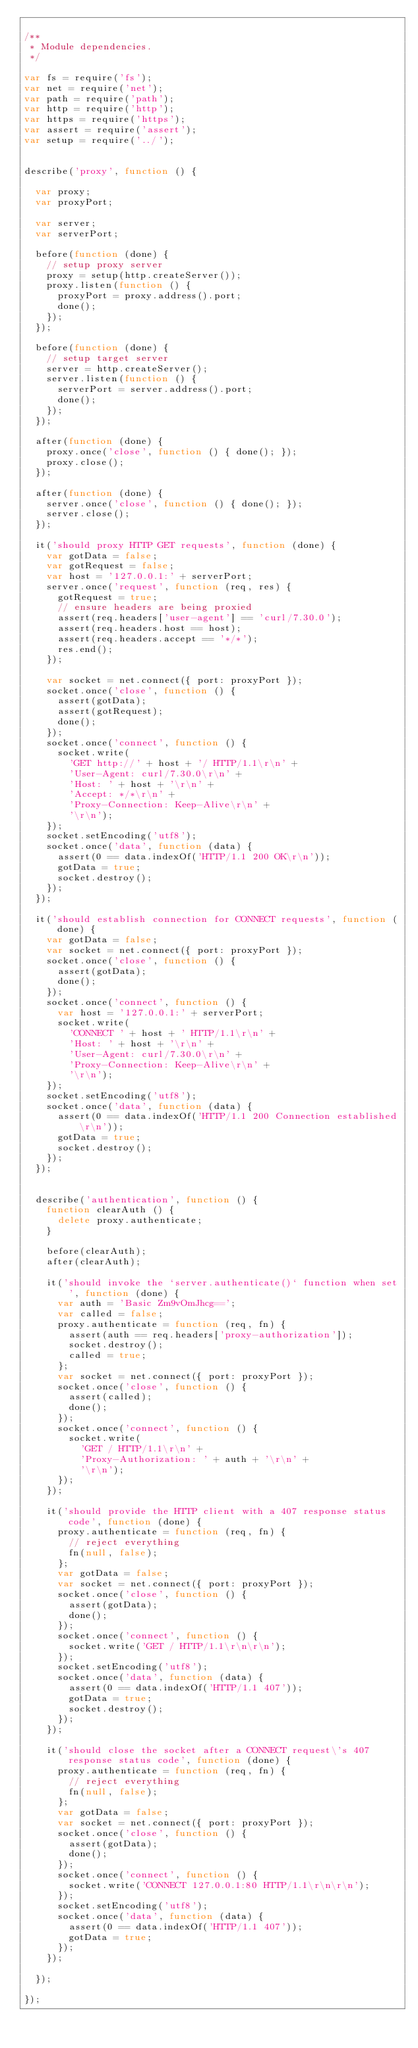<code> <loc_0><loc_0><loc_500><loc_500><_JavaScript_>
/**
 * Module dependencies.
 */

var fs = require('fs');
var net = require('net');
var path = require('path');
var http = require('http');
var https = require('https');
var assert = require('assert');
var setup = require('../');


describe('proxy', function () {

  var proxy;
  var proxyPort;

  var server;
  var serverPort;

  before(function (done) {
    // setup proxy server
    proxy = setup(http.createServer());
    proxy.listen(function () {
      proxyPort = proxy.address().port;
      done();
    });
  });

  before(function (done) {
    // setup target server
    server = http.createServer();
    server.listen(function () {
      serverPort = server.address().port;
      done();
    });
  });

  after(function (done) {
    proxy.once('close', function () { done(); });
    proxy.close();
  });

  after(function (done) {
    server.once('close', function () { done(); });
    server.close();
  });

  it('should proxy HTTP GET requests', function (done) {
    var gotData = false;
    var gotRequest = false;
    var host = '127.0.0.1:' + serverPort;
    server.once('request', function (req, res) {
      gotRequest = true;
      // ensure headers are being proxied
      assert(req.headers['user-agent'] == 'curl/7.30.0');
      assert(req.headers.host == host);
      assert(req.headers.accept == '*/*');
      res.end();
    });

    var socket = net.connect({ port: proxyPort });
    socket.once('close', function () {
      assert(gotData);
      assert(gotRequest);
      done();
    });
    socket.once('connect', function () {
      socket.write(
        'GET http://' + host + '/ HTTP/1.1\r\n' +
        'User-Agent: curl/7.30.0\r\n' +
        'Host: ' + host + '\r\n' +
        'Accept: */*\r\n' +
        'Proxy-Connection: Keep-Alive\r\n' +
        '\r\n');
    });
    socket.setEncoding('utf8');
    socket.once('data', function (data) {
      assert(0 == data.indexOf('HTTP/1.1 200 OK\r\n'));
      gotData = true;
      socket.destroy();
    });
  });

  it('should establish connection for CONNECT requests', function (done) {
    var gotData = false;
    var socket = net.connect({ port: proxyPort });
    socket.once('close', function () {
      assert(gotData);
      done();
    });
    socket.once('connect', function () {
      var host = '127.0.0.1:' + serverPort;
      socket.write(
        'CONNECT ' + host + ' HTTP/1.1\r\n' +
        'Host: ' + host + '\r\n' +
        'User-Agent: curl/7.30.0\r\n' +
        'Proxy-Connection: Keep-Alive\r\n' +
        '\r\n');
    });
    socket.setEncoding('utf8');
    socket.once('data', function (data) {
      assert(0 == data.indexOf('HTTP/1.1 200 Connection established\r\n'));
      gotData = true;
      socket.destroy();
    });
  });


  describe('authentication', function () {
    function clearAuth () {
      delete proxy.authenticate;
    }

    before(clearAuth);
    after(clearAuth);

    it('should invoke the `server.authenticate()` function when set', function (done) {
      var auth = 'Basic Zm9vOmJhcg==';
      var called = false;
      proxy.authenticate = function (req, fn) {
        assert(auth == req.headers['proxy-authorization']);
        socket.destroy();
        called = true;
      };
      var socket = net.connect({ port: proxyPort });
      socket.once('close', function () {
        assert(called);
        done();
      });
      socket.once('connect', function () {
        socket.write(
          'GET / HTTP/1.1\r\n' +
          'Proxy-Authorization: ' + auth + '\r\n' +
          '\r\n');
      });
    });

    it('should provide the HTTP client with a 407 response status code', function (done) {
      proxy.authenticate = function (req, fn) {
        // reject everything
        fn(null, false);
      };
      var gotData = false;
      var socket = net.connect({ port: proxyPort });
      socket.once('close', function () {
        assert(gotData);
        done();
      });
      socket.once('connect', function () {
        socket.write('GET / HTTP/1.1\r\n\r\n');
      });
      socket.setEncoding('utf8');
      socket.once('data', function (data) {
        assert(0 == data.indexOf('HTTP/1.1 407'));
        gotData = true;
        socket.destroy();
      });
    });

    it('should close the socket after a CONNECT request\'s 407 response status code', function (done) {
      proxy.authenticate = function (req, fn) {
        // reject everything
        fn(null, false);
      };
      var gotData = false;
      var socket = net.connect({ port: proxyPort });
      socket.once('close', function () {
        assert(gotData);
        done();
      });
      socket.once('connect', function () {
        socket.write('CONNECT 127.0.0.1:80 HTTP/1.1\r\n\r\n');
      });
      socket.setEncoding('utf8');
      socket.once('data', function (data) {
        assert(0 == data.indexOf('HTTP/1.1 407'));
        gotData = true;
      });
    });

  });

});
</code> 